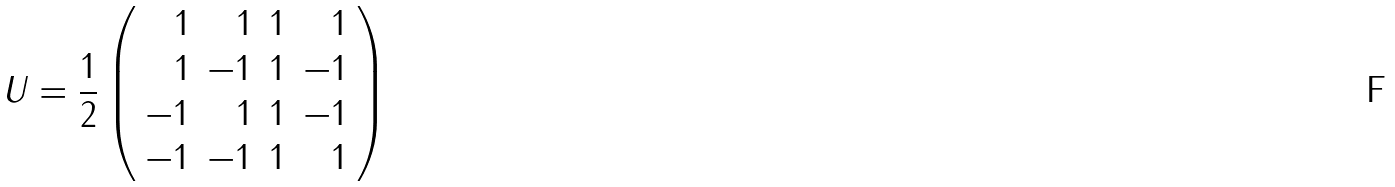<formula> <loc_0><loc_0><loc_500><loc_500>U = \frac { 1 } { 2 } \left ( \begin{array} { r r r r } 1 & 1 & 1 & 1 \\ 1 & - 1 & 1 & - 1 \\ - 1 & 1 & 1 & - 1 \\ - 1 & - 1 & 1 & 1 \end{array} \right )</formula> 